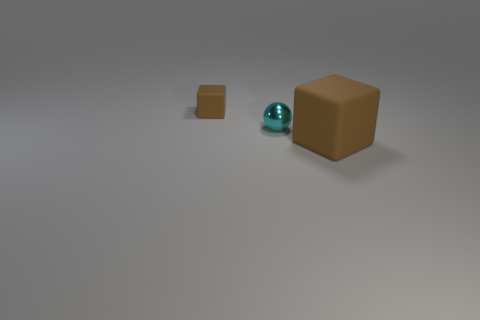Is there anything else that is made of the same material as the large brown cube?
Offer a very short reply. Yes. Is the number of large objects greater than the number of tiny red shiny spheres?
Your answer should be very brief. Yes. Do the block in front of the small brown thing and the matte thing that is behind the cyan metallic object have the same color?
Your answer should be compact. Yes. Are there any large brown matte cubes in front of the brown rubber cube on the right side of the tiny brown cube?
Offer a very short reply. No. Is the number of matte blocks that are left of the large object less than the number of tiny cyan balls that are behind the tiny block?
Offer a very short reply. No. Do the thing on the right side of the cyan object and the brown object to the left of the small metal thing have the same material?
Provide a short and direct response. Yes. What number of tiny objects are green shiny blocks or cyan things?
Your answer should be compact. 1. Are there fewer objects behind the large cube than big brown matte things?
Offer a very short reply. No. Is the small cyan thing the same shape as the large rubber object?
Keep it short and to the point. No. How many matte things are either small blocks or big blue objects?
Make the answer very short. 1. 